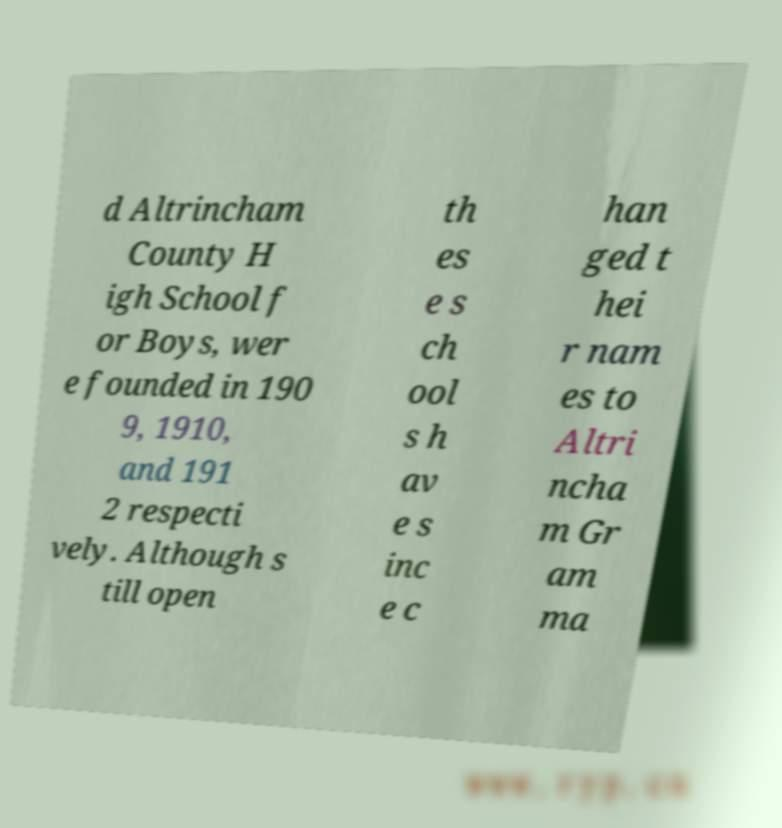Could you assist in decoding the text presented in this image and type it out clearly? d Altrincham County H igh School f or Boys, wer e founded in 190 9, 1910, and 191 2 respecti vely. Although s till open th es e s ch ool s h av e s inc e c han ged t hei r nam es to Altri ncha m Gr am ma 